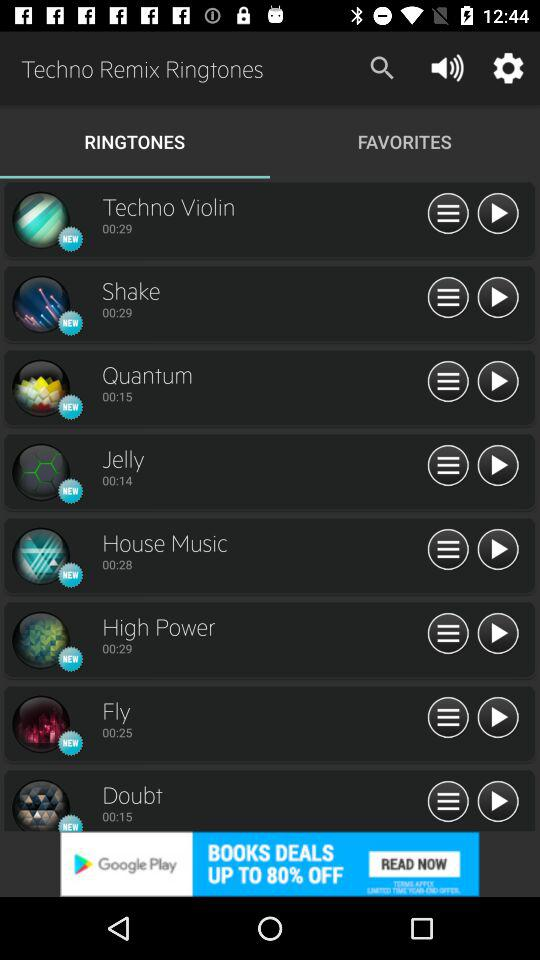How many more seconds does Techno Violin have than Quantum?
Answer the question using a single word or phrase. 14 